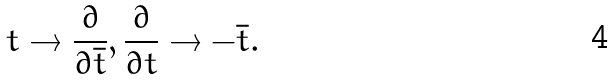Convert formula to latex. <formula><loc_0><loc_0><loc_500><loc_500>t \rightarrow \frac { \partial } { \partial \bar { t } } , \frac { \partial } { \partial t } \rightarrow - \bar { t } .</formula> 